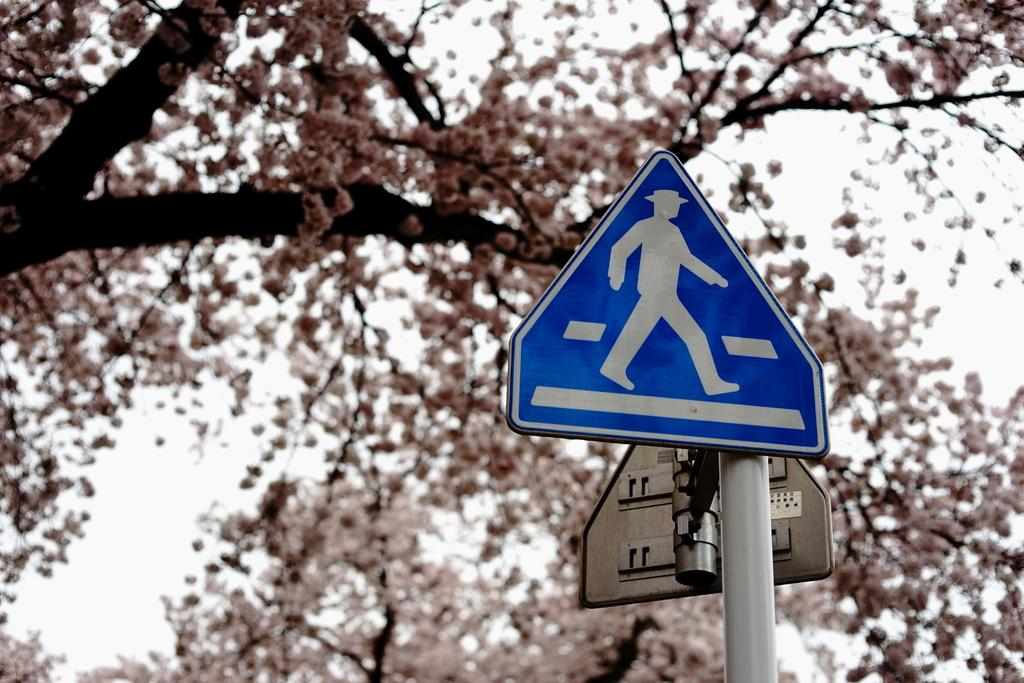What can be seen on the right side of the image? There are sign boards and a metal rod on the right side of the image. What is visible in the background of the image? There are trees and flowers in the background of the image. What type of trousers are hanging on the metal rod in the image? There are no trousers present in the image; the metal rod is not holding any clothing items. What effect does the presence of the sign boards have on the environment in the image? The provided facts do not mention any effect on the environment, so we cannot determine any impact from the sign boards. 